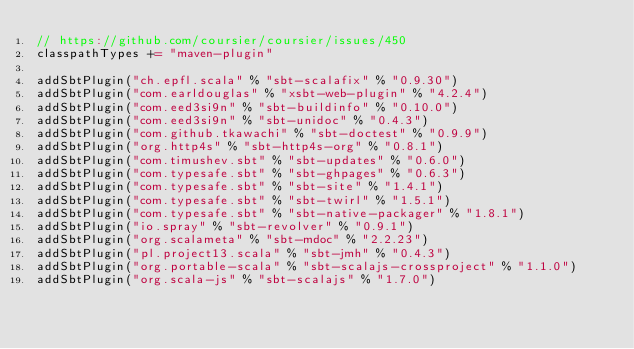<code> <loc_0><loc_0><loc_500><loc_500><_Scala_>// https://github.com/coursier/coursier/issues/450
classpathTypes += "maven-plugin"

addSbtPlugin("ch.epfl.scala" % "sbt-scalafix" % "0.9.30")
addSbtPlugin("com.earldouglas" % "xsbt-web-plugin" % "4.2.4")
addSbtPlugin("com.eed3si9n" % "sbt-buildinfo" % "0.10.0")
addSbtPlugin("com.eed3si9n" % "sbt-unidoc" % "0.4.3")
addSbtPlugin("com.github.tkawachi" % "sbt-doctest" % "0.9.9")
addSbtPlugin("org.http4s" % "sbt-http4s-org" % "0.8.1")
addSbtPlugin("com.timushev.sbt" % "sbt-updates" % "0.6.0")
addSbtPlugin("com.typesafe.sbt" % "sbt-ghpages" % "0.6.3")
addSbtPlugin("com.typesafe.sbt" % "sbt-site" % "1.4.1")
addSbtPlugin("com.typesafe.sbt" % "sbt-twirl" % "1.5.1")
addSbtPlugin("com.typesafe.sbt" % "sbt-native-packager" % "1.8.1")
addSbtPlugin("io.spray" % "sbt-revolver" % "0.9.1")
addSbtPlugin("org.scalameta" % "sbt-mdoc" % "2.2.23")
addSbtPlugin("pl.project13.scala" % "sbt-jmh" % "0.4.3")
addSbtPlugin("org.portable-scala" % "sbt-scalajs-crossproject" % "1.1.0")
addSbtPlugin("org.scala-js" % "sbt-scalajs" % "1.7.0")</code> 